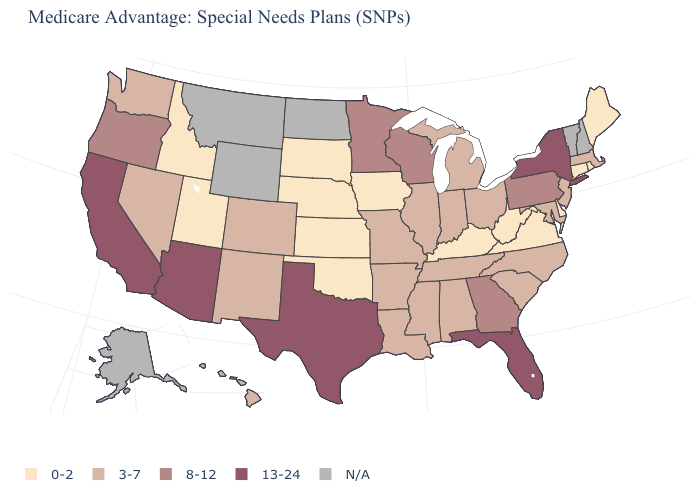Does the map have missing data?
Short answer required. Yes. Is the legend a continuous bar?
Quick response, please. No. Does Arizona have the highest value in the USA?
Quick response, please. Yes. What is the value of Connecticut?
Quick response, please. 0-2. Which states have the highest value in the USA?
Keep it brief. Arizona, California, Florida, New York, Texas. Does Tennessee have the lowest value in the USA?
Give a very brief answer. No. Which states hav the highest value in the South?
Keep it brief. Florida, Texas. What is the value of Louisiana?
Write a very short answer. 3-7. What is the value of Alabama?
Keep it brief. 3-7. What is the highest value in the West ?
Concise answer only. 13-24. Which states have the lowest value in the MidWest?
Be succinct. Iowa, Kansas, Nebraska, South Dakota. Which states hav the highest value in the South?
Give a very brief answer. Florida, Texas. Among the states that border Missouri , does Illinois have the highest value?
Be succinct. Yes. What is the highest value in the USA?
Give a very brief answer. 13-24. Name the states that have a value in the range 13-24?
Keep it brief. Arizona, California, Florida, New York, Texas. 